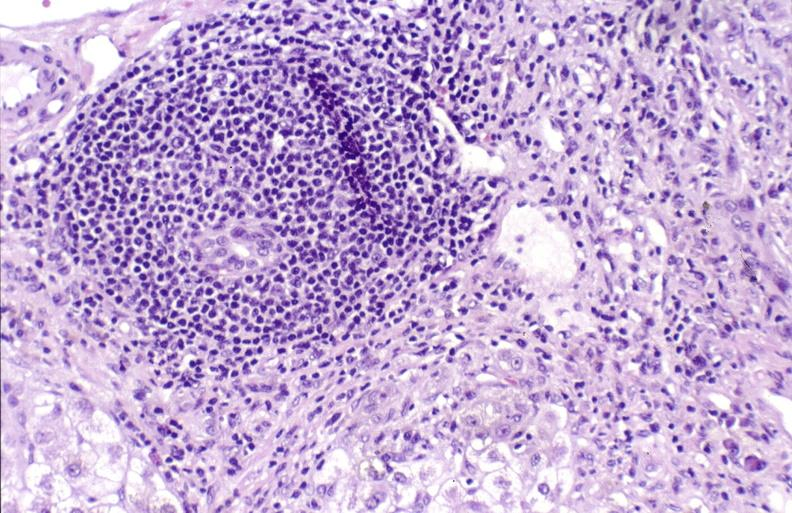s hepatobiliary present?
Answer the question using a single word or phrase. Yes 